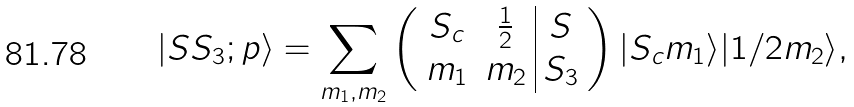<formula> <loc_0><loc_0><loc_500><loc_500>| S S _ { 3 } ; p \rangle = \sum _ { m _ { 1 } , m _ { 2 } } \left ( \begin{array} { c c | c } S _ { c } & \frac { 1 } { 2 } & S \\ m _ { 1 } & m _ { 2 } & S _ { 3 } \end{array} \right ) | S _ { c } m _ { 1 } \rangle | 1 / 2 m _ { 2 } \rangle ,</formula> 